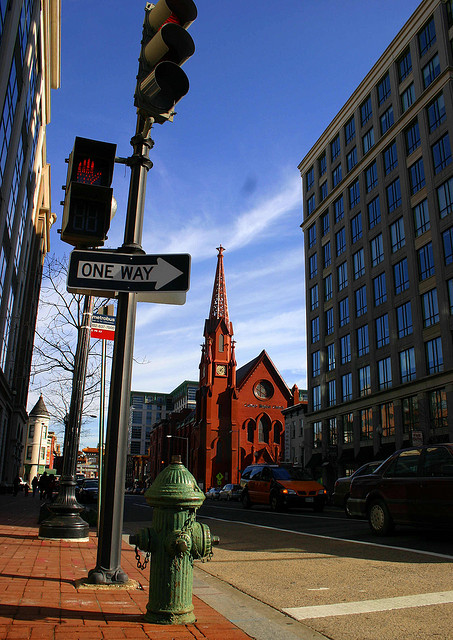Please transcribe the text in this image. ONE WAY 